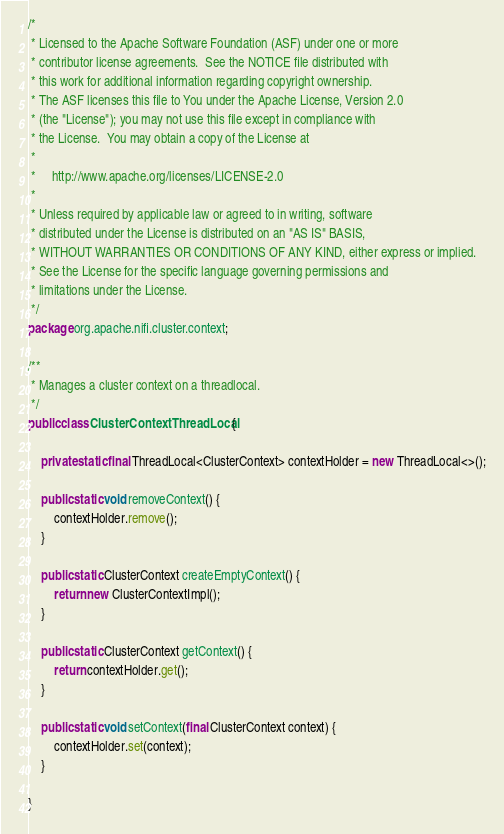Convert code to text. <code><loc_0><loc_0><loc_500><loc_500><_Java_>/*
 * Licensed to the Apache Software Foundation (ASF) under one or more
 * contributor license agreements.  See the NOTICE file distributed with
 * this work for additional information regarding copyright ownership.
 * The ASF licenses this file to You under the Apache License, Version 2.0
 * (the "License"); you may not use this file except in compliance with
 * the License.  You may obtain a copy of the License at
 *
 *     http://www.apache.org/licenses/LICENSE-2.0
 *
 * Unless required by applicable law or agreed to in writing, software
 * distributed under the License is distributed on an "AS IS" BASIS,
 * WITHOUT WARRANTIES OR CONDITIONS OF ANY KIND, either express or implied.
 * See the License for the specific language governing permissions and
 * limitations under the License.
 */
package org.apache.nifi.cluster.context;

/**
 * Manages a cluster context on a threadlocal.
 */
public class ClusterContextThreadLocal {

    private static final ThreadLocal<ClusterContext> contextHolder = new ThreadLocal<>();

    public static void removeContext() {
        contextHolder.remove();
    }

    public static ClusterContext createEmptyContext() {
        return new ClusterContextImpl();
    }

    public static ClusterContext getContext() {
        return contextHolder.get();
    }

    public static void setContext(final ClusterContext context) {
        contextHolder.set(context);
    }

}
</code> 